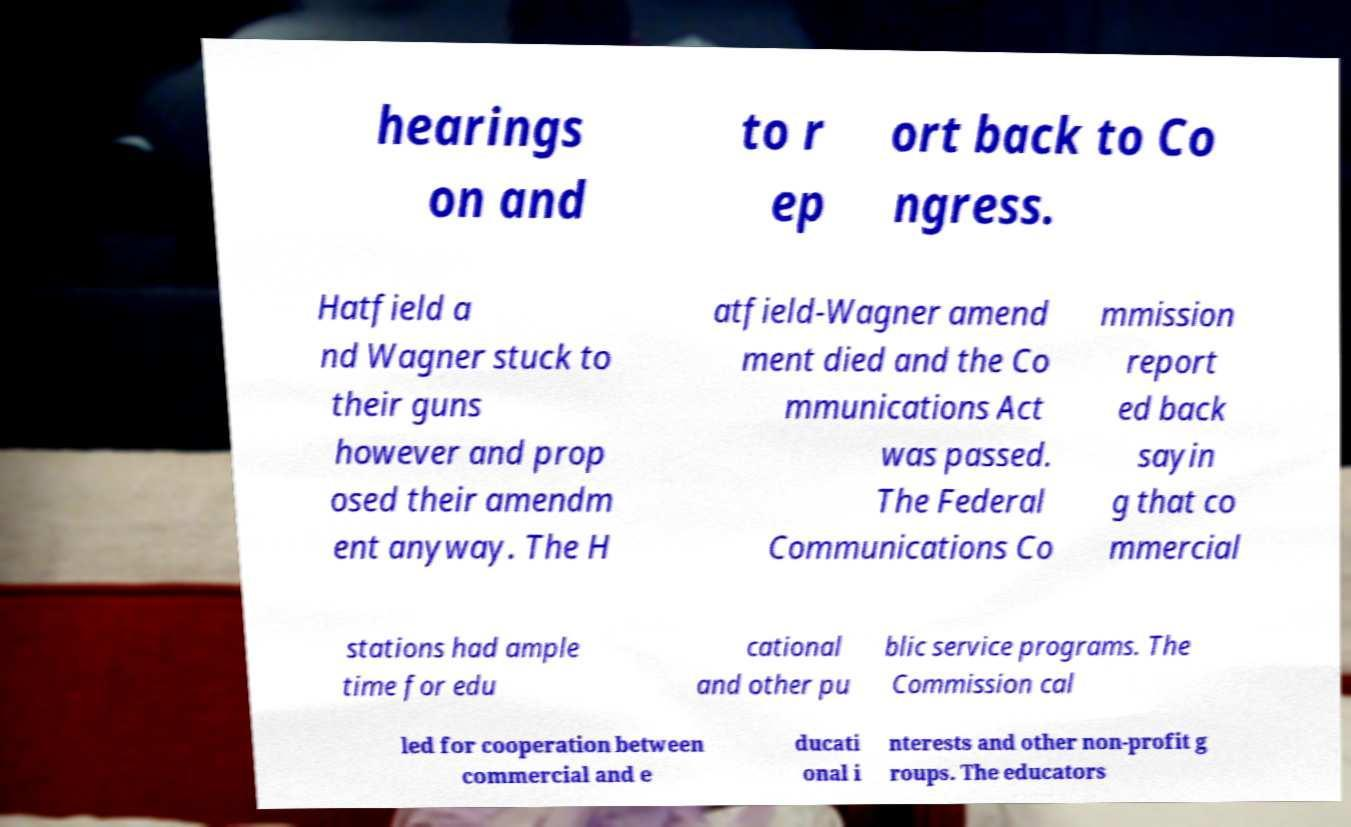Please read and relay the text visible in this image. What does it say? hearings on and to r ep ort back to Co ngress. Hatfield a nd Wagner stuck to their guns however and prop osed their amendm ent anyway. The H atfield-Wagner amend ment died and the Co mmunications Act was passed. The Federal Communications Co mmission report ed back sayin g that co mmercial stations had ample time for edu cational and other pu blic service programs. The Commission cal led for cooperation between commercial and e ducati onal i nterests and other non-profit g roups. The educators 